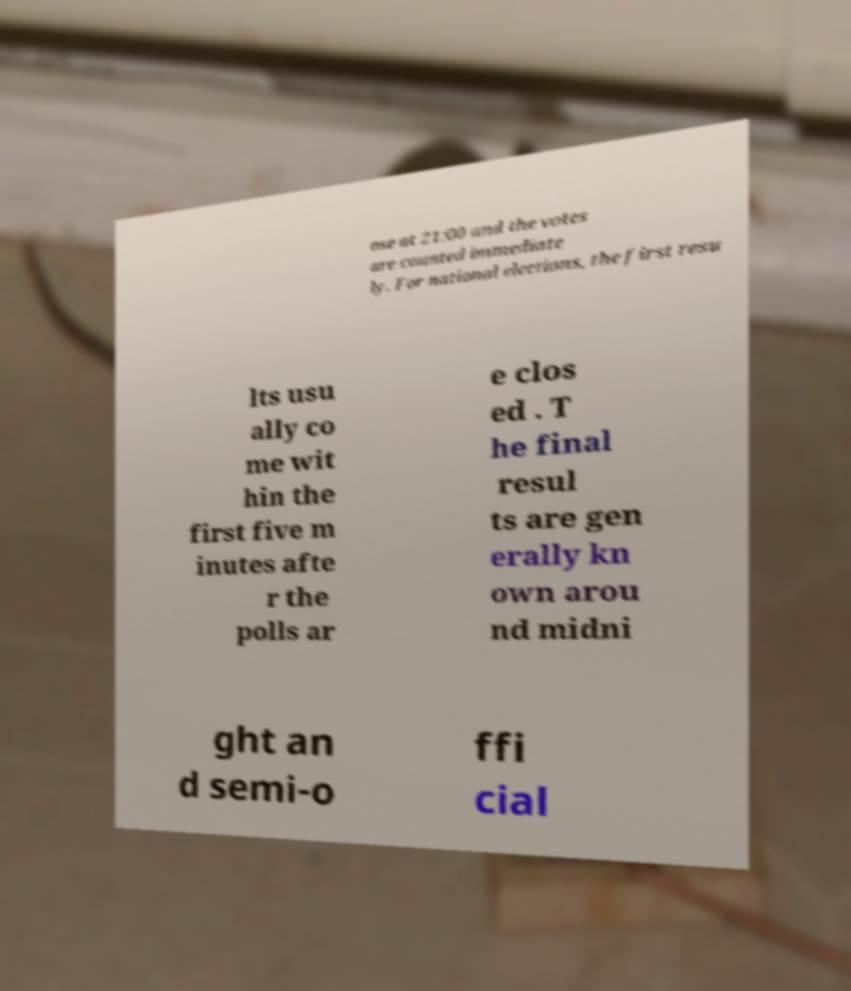I need the written content from this picture converted into text. Can you do that? ose at 21:00 and the votes are counted immediate ly. For national elections, the first resu lts usu ally co me wit hin the first five m inutes afte r the polls ar e clos ed . T he final resul ts are gen erally kn own arou nd midni ght an d semi-o ffi cial 